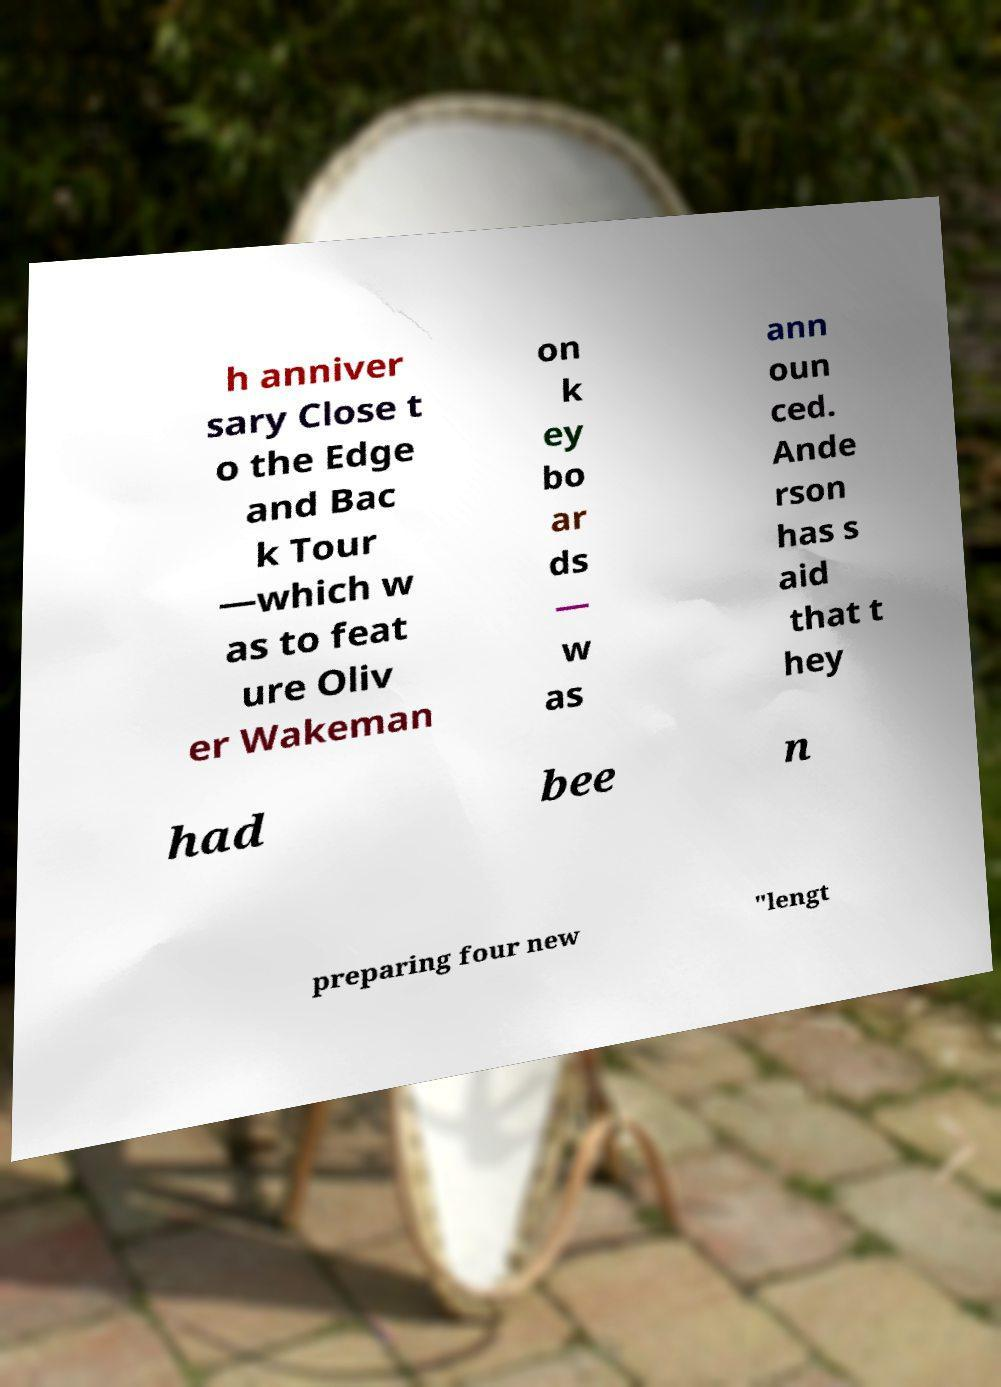For documentation purposes, I need the text within this image transcribed. Could you provide that? h anniver sary Close t o the Edge and Bac k Tour —which w as to feat ure Oliv er Wakeman on k ey bo ar ds — w as ann oun ced. Ande rson has s aid that t hey had bee n preparing four new "lengt 